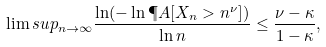Convert formula to latex. <formula><loc_0><loc_0><loc_500><loc_500>\lim s u p _ { n \to \infty } \frac { \ln ( - \ln \P A [ X _ { n } > n ^ { \nu } ] ) } { \ln n } \leq \frac { \nu - \kappa } { 1 - \kappa } ,</formula> 